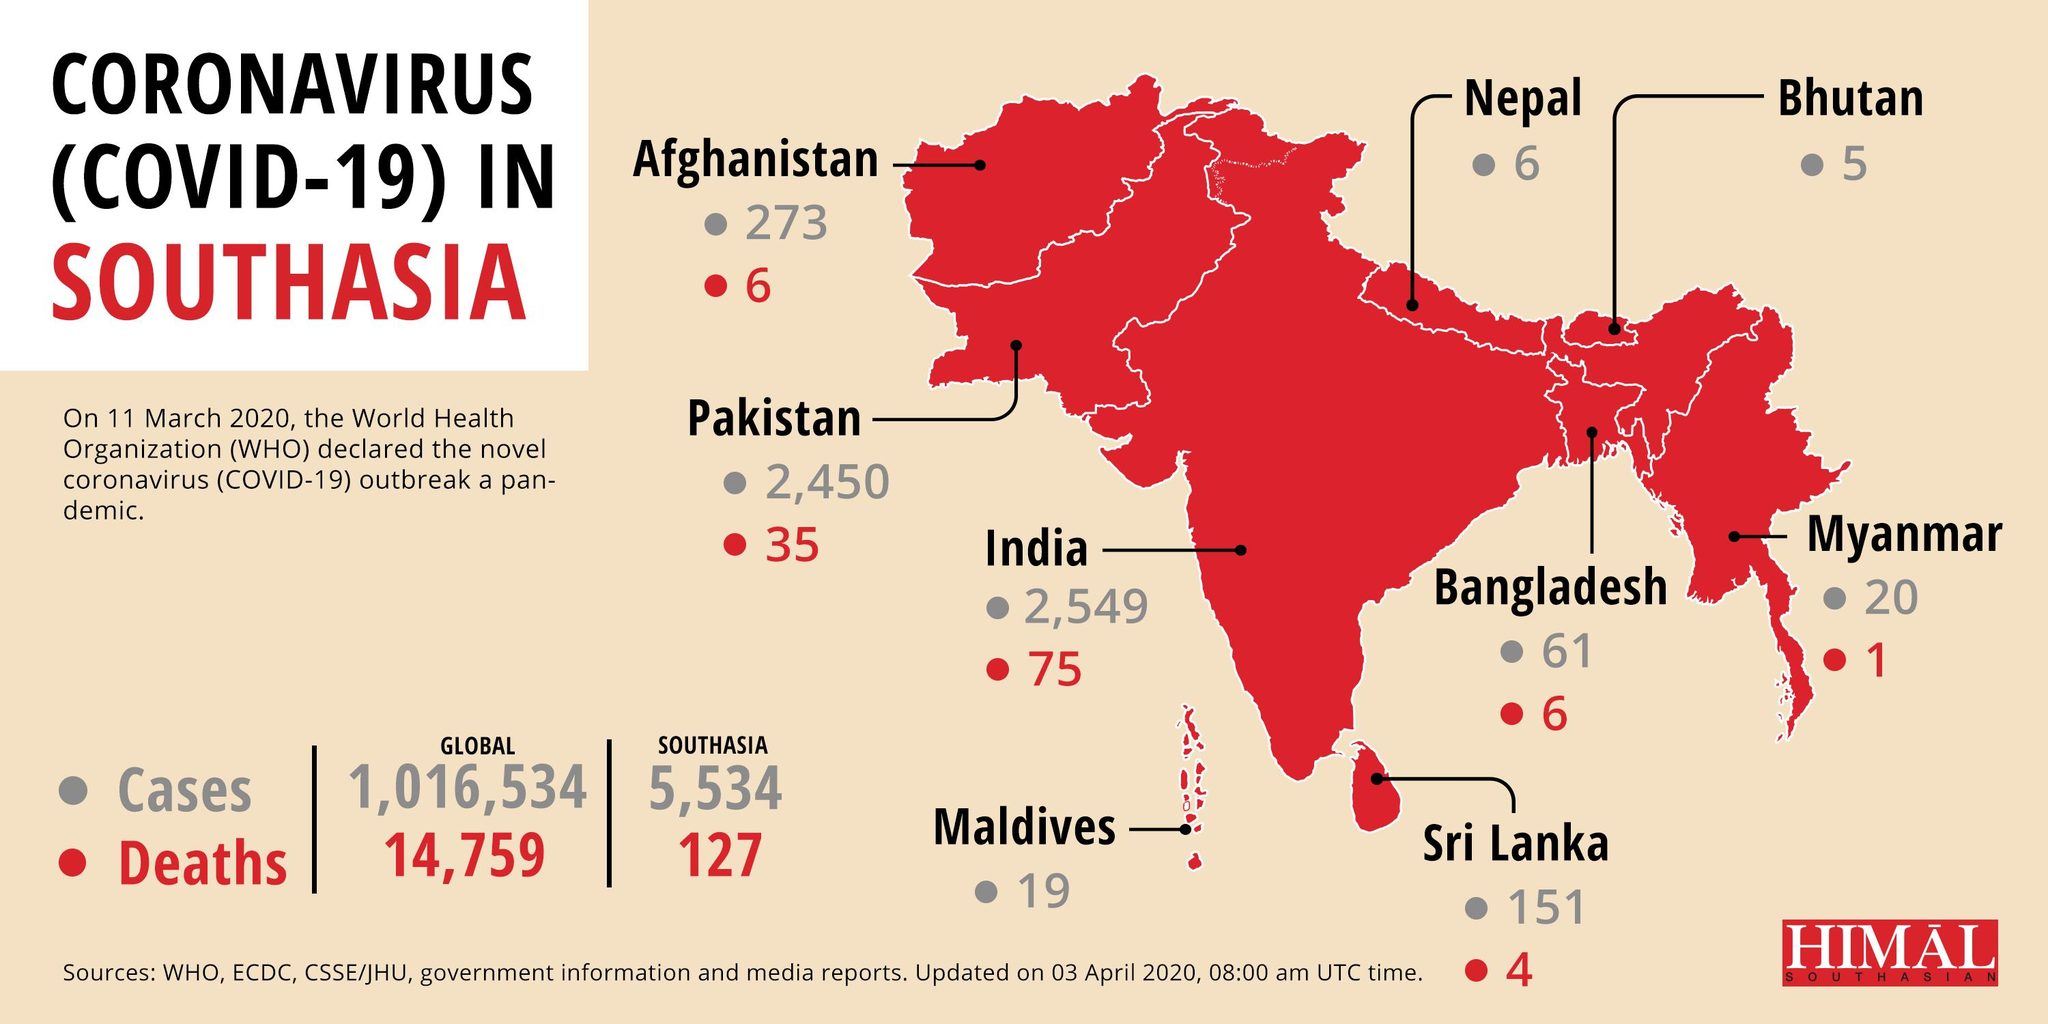Mention a couple of crucial points in this snapshot. As of April 3, 2020, the number of Covid-19 deaths reported in Bangladesh was 6. Bhutan has reported the least number of COVID-19 cases among South Asian countries as of April 3, 2020. According to the most recent data available as of April 3, 2020, a total of 4 Covid-19 deaths had been reported in Sri Lanka. As of April 3, 2020, the number of COVID-19 cases reported in Myanmar was 20. As of April 3, 2020, the South Asian country with the highest number of COVID-19 cases is India. 